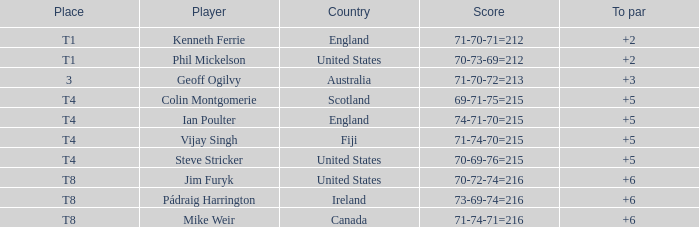Who had a score of 70-73-69=212? Phil Mickelson. 